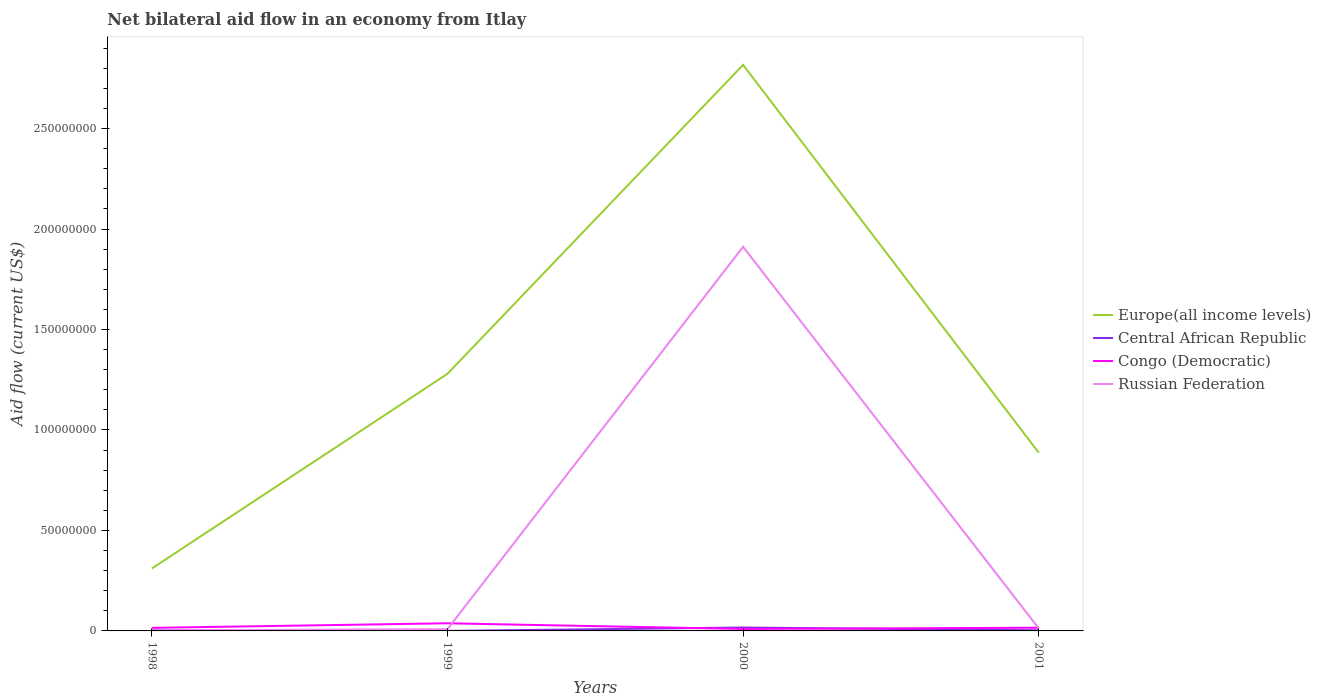How many different coloured lines are there?
Offer a very short reply. 4. Does the line corresponding to Russian Federation intersect with the line corresponding to Congo (Democratic)?
Your response must be concise. Yes. Is the number of lines equal to the number of legend labels?
Offer a very short reply. Yes. What is the total net bilateral aid flow in Congo (Democratic) in the graph?
Make the answer very short. -2.28e+06. What is the difference between the highest and the second highest net bilateral aid flow in Europe(all income levels)?
Your answer should be compact. 2.51e+08. What is the difference between the highest and the lowest net bilateral aid flow in Europe(all income levels)?
Offer a very short reply. 1. How many lines are there?
Provide a short and direct response. 4. What is the difference between two consecutive major ticks on the Y-axis?
Your answer should be compact. 5.00e+07. Where does the legend appear in the graph?
Make the answer very short. Center right. How are the legend labels stacked?
Ensure brevity in your answer.  Vertical. What is the title of the graph?
Your answer should be very brief. Net bilateral aid flow in an economy from Itlay. What is the label or title of the Y-axis?
Provide a short and direct response. Aid flow (current US$). What is the Aid flow (current US$) of Europe(all income levels) in 1998?
Provide a succinct answer. 3.11e+07. What is the Aid flow (current US$) of Congo (Democratic) in 1998?
Keep it short and to the point. 1.52e+06. What is the Aid flow (current US$) of Russian Federation in 1998?
Provide a succinct answer. 3.00e+05. What is the Aid flow (current US$) in Europe(all income levels) in 1999?
Your answer should be very brief. 1.28e+08. What is the Aid flow (current US$) of Central African Republic in 1999?
Provide a short and direct response. 10000. What is the Aid flow (current US$) of Congo (Democratic) in 1999?
Offer a terse response. 3.80e+06. What is the Aid flow (current US$) in Russian Federation in 1999?
Your answer should be compact. 8.80e+05. What is the Aid flow (current US$) in Europe(all income levels) in 2000?
Your answer should be very brief. 2.82e+08. What is the Aid flow (current US$) of Central African Republic in 2000?
Provide a short and direct response. 1.69e+06. What is the Aid flow (current US$) in Congo (Democratic) in 2000?
Your response must be concise. 9.60e+05. What is the Aid flow (current US$) of Russian Federation in 2000?
Your response must be concise. 1.91e+08. What is the Aid flow (current US$) in Europe(all income levels) in 2001?
Offer a very short reply. 8.87e+07. What is the Aid flow (current US$) in Congo (Democratic) in 2001?
Ensure brevity in your answer.  1.59e+06. What is the Aid flow (current US$) of Russian Federation in 2001?
Make the answer very short. 1.28e+06. Across all years, what is the maximum Aid flow (current US$) of Europe(all income levels)?
Provide a succinct answer. 2.82e+08. Across all years, what is the maximum Aid flow (current US$) in Central African Republic?
Keep it short and to the point. 1.69e+06. Across all years, what is the maximum Aid flow (current US$) in Congo (Democratic)?
Your response must be concise. 3.80e+06. Across all years, what is the maximum Aid flow (current US$) in Russian Federation?
Make the answer very short. 1.91e+08. Across all years, what is the minimum Aid flow (current US$) in Europe(all income levels)?
Offer a terse response. 3.11e+07. Across all years, what is the minimum Aid flow (current US$) of Central African Republic?
Provide a short and direct response. 10000. Across all years, what is the minimum Aid flow (current US$) in Congo (Democratic)?
Your answer should be compact. 9.60e+05. What is the total Aid flow (current US$) of Europe(all income levels) in the graph?
Give a very brief answer. 5.29e+08. What is the total Aid flow (current US$) of Central African Republic in the graph?
Offer a terse response. 2.34e+06. What is the total Aid flow (current US$) of Congo (Democratic) in the graph?
Your answer should be very brief. 7.87e+06. What is the total Aid flow (current US$) in Russian Federation in the graph?
Keep it short and to the point. 1.94e+08. What is the difference between the Aid flow (current US$) of Europe(all income levels) in 1998 and that in 1999?
Give a very brief answer. -9.69e+07. What is the difference between the Aid flow (current US$) of Central African Republic in 1998 and that in 1999?
Your answer should be compact. 3.10e+05. What is the difference between the Aid flow (current US$) in Congo (Democratic) in 1998 and that in 1999?
Provide a short and direct response. -2.28e+06. What is the difference between the Aid flow (current US$) of Russian Federation in 1998 and that in 1999?
Your response must be concise. -5.80e+05. What is the difference between the Aid flow (current US$) of Europe(all income levels) in 1998 and that in 2000?
Give a very brief answer. -2.51e+08. What is the difference between the Aid flow (current US$) in Central African Republic in 1998 and that in 2000?
Your response must be concise. -1.37e+06. What is the difference between the Aid flow (current US$) in Congo (Democratic) in 1998 and that in 2000?
Keep it short and to the point. 5.60e+05. What is the difference between the Aid flow (current US$) in Russian Federation in 1998 and that in 2000?
Your answer should be very brief. -1.91e+08. What is the difference between the Aid flow (current US$) in Europe(all income levels) in 1998 and that in 2001?
Give a very brief answer. -5.77e+07. What is the difference between the Aid flow (current US$) in Central African Republic in 1998 and that in 2001?
Your answer should be compact. 0. What is the difference between the Aid flow (current US$) of Russian Federation in 1998 and that in 2001?
Your answer should be compact. -9.80e+05. What is the difference between the Aid flow (current US$) in Europe(all income levels) in 1999 and that in 2000?
Your answer should be very brief. -1.54e+08. What is the difference between the Aid flow (current US$) of Central African Republic in 1999 and that in 2000?
Offer a very short reply. -1.68e+06. What is the difference between the Aid flow (current US$) of Congo (Democratic) in 1999 and that in 2000?
Ensure brevity in your answer.  2.84e+06. What is the difference between the Aid flow (current US$) in Russian Federation in 1999 and that in 2000?
Provide a short and direct response. -1.90e+08. What is the difference between the Aid flow (current US$) of Europe(all income levels) in 1999 and that in 2001?
Give a very brief answer. 3.92e+07. What is the difference between the Aid flow (current US$) of Central African Republic in 1999 and that in 2001?
Provide a succinct answer. -3.10e+05. What is the difference between the Aid flow (current US$) of Congo (Democratic) in 1999 and that in 2001?
Offer a very short reply. 2.21e+06. What is the difference between the Aid flow (current US$) of Russian Federation in 1999 and that in 2001?
Offer a very short reply. -4.00e+05. What is the difference between the Aid flow (current US$) in Europe(all income levels) in 2000 and that in 2001?
Offer a terse response. 1.93e+08. What is the difference between the Aid flow (current US$) in Central African Republic in 2000 and that in 2001?
Your response must be concise. 1.37e+06. What is the difference between the Aid flow (current US$) in Congo (Democratic) in 2000 and that in 2001?
Provide a short and direct response. -6.30e+05. What is the difference between the Aid flow (current US$) in Russian Federation in 2000 and that in 2001?
Your answer should be compact. 1.90e+08. What is the difference between the Aid flow (current US$) of Europe(all income levels) in 1998 and the Aid flow (current US$) of Central African Republic in 1999?
Your answer should be very brief. 3.10e+07. What is the difference between the Aid flow (current US$) in Europe(all income levels) in 1998 and the Aid flow (current US$) in Congo (Democratic) in 1999?
Offer a terse response. 2.73e+07. What is the difference between the Aid flow (current US$) in Europe(all income levels) in 1998 and the Aid flow (current US$) in Russian Federation in 1999?
Provide a short and direct response. 3.02e+07. What is the difference between the Aid flow (current US$) in Central African Republic in 1998 and the Aid flow (current US$) in Congo (Democratic) in 1999?
Make the answer very short. -3.48e+06. What is the difference between the Aid flow (current US$) in Central African Republic in 1998 and the Aid flow (current US$) in Russian Federation in 1999?
Provide a succinct answer. -5.60e+05. What is the difference between the Aid flow (current US$) in Congo (Democratic) in 1998 and the Aid flow (current US$) in Russian Federation in 1999?
Your response must be concise. 6.40e+05. What is the difference between the Aid flow (current US$) of Europe(all income levels) in 1998 and the Aid flow (current US$) of Central African Republic in 2000?
Give a very brief answer. 2.94e+07. What is the difference between the Aid flow (current US$) in Europe(all income levels) in 1998 and the Aid flow (current US$) in Congo (Democratic) in 2000?
Your answer should be compact. 3.01e+07. What is the difference between the Aid flow (current US$) in Europe(all income levels) in 1998 and the Aid flow (current US$) in Russian Federation in 2000?
Make the answer very short. -1.60e+08. What is the difference between the Aid flow (current US$) of Central African Republic in 1998 and the Aid flow (current US$) of Congo (Democratic) in 2000?
Ensure brevity in your answer.  -6.40e+05. What is the difference between the Aid flow (current US$) in Central African Republic in 1998 and the Aid flow (current US$) in Russian Federation in 2000?
Provide a short and direct response. -1.91e+08. What is the difference between the Aid flow (current US$) in Congo (Democratic) in 1998 and the Aid flow (current US$) in Russian Federation in 2000?
Your answer should be very brief. -1.90e+08. What is the difference between the Aid flow (current US$) of Europe(all income levels) in 1998 and the Aid flow (current US$) of Central African Republic in 2001?
Your response must be concise. 3.07e+07. What is the difference between the Aid flow (current US$) in Europe(all income levels) in 1998 and the Aid flow (current US$) in Congo (Democratic) in 2001?
Make the answer very short. 2.95e+07. What is the difference between the Aid flow (current US$) of Europe(all income levels) in 1998 and the Aid flow (current US$) of Russian Federation in 2001?
Keep it short and to the point. 2.98e+07. What is the difference between the Aid flow (current US$) of Central African Republic in 1998 and the Aid flow (current US$) of Congo (Democratic) in 2001?
Give a very brief answer. -1.27e+06. What is the difference between the Aid flow (current US$) of Central African Republic in 1998 and the Aid flow (current US$) of Russian Federation in 2001?
Keep it short and to the point. -9.60e+05. What is the difference between the Aid flow (current US$) of Congo (Democratic) in 1998 and the Aid flow (current US$) of Russian Federation in 2001?
Your answer should be compact. 2.40e+05. What is the difference between the Aid flow (current US$) in Europe(all income levels) in 1999 and the Aid flow (current US$) in Central African Republic in 2000?
Your answer should be compact. 1.26e+08. What is the difference between the Aid flow (current US$) of Europe(all income levels) in 1999 and the Aid flow (current US$) of Congo (Democratic) in 2000?
Keep it short and to the point. 1.27e+08. What is the difference between the Aid flow (current US$) of Europe(all income levels) in 1999 and the Aid flow (current US$) of Russian Federation in 2000?
Ensure brevity in your answer.  -6.32e+07. What is the difference between the Aid flow (current US$) in Central African Republic in 1999 and the Aid flow (current US$) in Congo (Democratic) in 2000?
Offer a very short reply. -9.50e+05. What is the difference between the Aid flow (current US$) of Central African Republic in 1999 and the Aid flow (current US$) of Russian Federation in 2000?
Give a very brief answer. -1.91e+08. What is the difference between the Aid flow (current US$) in Congo (Democratic) in 1999 and the Aid flow (current US$) in Russian Federation in 2000?
Offer a very short reply. -1.87e+08. What is the difference between the Aid flow (current US$) in Europe(all income levels) in 1999 and the Aid flow (current US$) in Central African Republic in 2001?
Make the answer very short. 1.28e+08. What is the difference between the Aid flow (current US$) in Europe(all income levels) in 1999 and the Aid flow (current US$) in Congo (Democratic) in 2001?
Give a very brief answer. 1.26e+08. What is the difference between the Aid flow (current US$) of Europe(all income levels) in 1999 and the Aid flow (current US$) of Russian Federation in 2001?
Your answer should be very brief. 1.27e+08. What is the difference between the Aid flow (current US$) in Central African Republic in 1999 and the Aid flow (current US$) in Congo (Democratic) in 2001?
Offer a terse response. -1.58e+06. What is the difference between the Aid flow (current US$) in Central African Republic in 1999 and the Aid flow (current US$) in Russian Federation in 2001?
Ensure brevity in your answer.  -1.27e+06. What is the difference between the Aid flow (current US$) of Congo (Democratic) in 1999 and the Aid flow (current US$) of Russian Federation in 2001?
Offer a terse response. 2.52e+06. What is the difference between the Aid flow (current US$) of Europe(all income levels) in 2000 and the Aid flow (current US$) of Central African Republic in 2001?
Your answer should be compact. 2.81e+08. What is the difference between the Aid flow (current US$) in Europe(all income levels) in 2000 and the Aid flow (current US$) in Congo (Democratic) in 2001?
Provide a succinct answer. 2.80e+08. What is the difference between the Aid flow (current US$) of Europe(all income levels) in 2000 and the Aid flow (current US$) of Russian Federation in 2001?
Ensure brevity in your answer.  2.80e+08. What is the difference between the Aid flow (current US$) in Central African Republic in 2000 and the Aid flow (current US$) in Congo (Democratic) in 2001?
Ensure brevity in your answer.  1.00e+05. What is the difference between the Aid flow (current US$) in Central African Republic in 2000 and the Aid flow (current US$) in Russian Federation in 2001?
Keep it short and to the point. 4.10e+05. What is the difference between the Aid flow (current US$) in Congo (Democratic) in 2000 and the Aid flow (current US$) in Russian Federation in 2001?
Your response must be concise. -3.20e+05. What is the average Aid flow (current US$) in Europe(all income levels) per year?
Provide a short and direct response. 1.32e+08. What is the average Aid flow (current US$) in Central African Republic per year?
Ensure brevity in your answer.  5.85e+05. What is the average Aid flow (current US$) of Congo (Democratic) per year?
Your answer should be compact. 1.97e+06. What is the average Aid flow (current US$) in Russian Federation per year?
Keep it short and to the point. 4.84e+07. In the year 1998, what is the difference between the Aid flow (current US$) of Europe(all income levels) and Aid flow (current US$) of Central African Republic?
Offer a terse response. 3.07e+07. In the year 1998, what is the difference between the Aid flow (current US$) in Europe(all income levels) and Aid flow (current US$) in Congo (Democratic)?
Offer a very short reply. 2.95e+07. In the year 1998, what is the difference between the Aid flow (current US$) of Europe(all income levels) and Aid flow (current US$) of Russian Federation?
Your answer should be very brief. 3.08e+07. In the year 1998, what is the difference between the Aid flow (current US$) in Central African Republic and Aid flow (current US$) in Congo (Democratic)?
Provide a short and direct response. -1.20e+06. In the year 1998, what is the difference between the Aid flow (current US$) of Congo (Democratic) and Aid flow (current US$) of Russian Federation?
Offer a terse response. 1.22e+06. In the year 1999, what is the difference between the Aid flow (current US$) in Europe(all income levels) and Aid flow (current US$) in Central African Republic?
Keep it short and to the point. 1.28e+08. In the year 1999, what is the difference between the Aid flow (current US$) of Europe(all income levels) and Aid flow (current US$) of Congo (Democratic)?
Offer a terse response. 1.24e+08. In the year 1999, what is the difference between the Aid flow (current US$) in Europe(all income levels) and Aid flow (current US$) in Russian Federation?
Offer a terse response. 1.27e+08. In the year 1999, what is the difference between the Aid flow (current US$) in Central African Republic and Aid flow (current US$) in Congo (Democratic)?
Offer a terse response. -3.79e+06. In the year 1999, what is the difference between the Aid flow (current US$) of Central African Republic and Aid flow (current US$) of Russian Federation?
Your response must be concise. -8.70e+05. In the year 1999, what is the difference between the Aid flow (current US$) of Congo (Democratic) and Aid flow (current US$) of Russian Federation?
Provide a succinct answer. 2.92e+06. In the year 2000, what is the difference between the Aid flow (current US$) of Europe(all income levels) and Aid flow (current US$) of Central African Republic?
Provide a short and direct response. 2.80e+08. In the year 2000, what is the difference between the Aid flow (current US$) of Europe(all income levels) and Aid flow (current US$) of Congo (Democratic)?
Offer a very short reply. 2.81e+08. In the year 2000, what is the difference between the Aid flow (current US$) in Europe(all income levels) and Aid flow (current US$) in Russian Federation?
Give a very brief answer. 9.05e+07. In the year 2000, what is the difference between the Aid flow (current US$) in Central African Republic and Aid flow (current US$) in Congo (Democratic)?
Offer a terse response. 7.30e+05. In the year 2000, what is the difference between the Aid flow (current US$) in Central African Republic and Aid flow (current US$) in Russian Federation?
Offer a very short reply. -1.89e+08. In the year 2000, what is the difference between the Aid flow (current US$) of Congo (Democratic) and Aid flow (current US$) of Russian Federation?
Make the answer very short. -1.90e+08. In the year 2001, what is the difference between the Aid flow (current US$) of Europe(all income levels) and Aid flow (current US$) of Central African Republic?
Give a very brief answer. 8.84e+07. In the year 2001, what is the difference between the Aid flow (current US$) of Europe(all income levels) and Aid flow (current US$) of Congo (Democratic)?
Keep it short and to the point. 8.71e+07. In the year 2001, what is the difference between the Aid flow (current US$) in Europe(all income levels) and Aid flow (current US$) in Russian Federation?
Make the answer very short. 8.74e+07. In the year 2001, what is the difference between the Aid flow (current US$) of Central African Republic and Aid flow (current US$) of Congo (Democratic)?
Your answer should be very brief. -1.27e+06. In the year 2001, what is the difference between the Aid flow (current US$) of Central African Republic and Aid flow (current US$) of Russian Federation?
Give a very brief answer. -9.60e+05. What is the ratio of the Aid flow (current US$) of Europe(all income levels) in 1998 to that in 1999?
Keep it short and to the point. 0.24. What is the ratio of the Aid flow (current US$) in Congo (Democratic) in 1998 to that in 1999?
Your answer should be compact. 0.4. What is the ratio of the Aid flow (current US$) of Russian Federation in 1998 to that in 1999?
Your answer should be compact. 0.34. What is the ratio of the Aid flow (current US$) of Europe(all income levels) in 1998 to that in 2000?
Your answer should be compact. 0.11. What is the ratio of the Aid flow (current US$) in Central African Republic in 1998 to that in 2000?
Offer a terse response. 0.19. What is the ratio of the Aid flow (current US$) of Congo (Democratic) in 1998 to that in 2000?
Keep it short and to the point. 1.58. What is the ratio of the Aid flow (current US$) of Russian Federation in 1998 to that in 2000?
Give a very brief answer. 0. What is the ratio of the Aid flow (current US$) of Europe(all income levels) in 1998 to that in 2001?
Ensure brevity in your answer.  0.35. What is the ratio of the Aid flow (current US$) in Congo (Democratic) in 1998 to that in 2001?
Ensure brevity in your answer.  0.96. What is the ratio of the Aid flow (current US$) in Russian Federation in 1998 to that in 2001?
Your answer should be compact. 0.23. What is the ratio of the Aid flow (current US$) in Europe(all income levels) in 1999 to that in 2000?
Your answer should be compact. 0.45. What is the ratio of the Aid flow (current US$) in Central African Republic in 1999 to that in 2000?
Provide a short and direct response. 0.01. What is the ratio of the Aid flow (current US$) in Congo (Democratic) in 1999 to that in 2000?
Make the answer very short. 3.96. What is the ratio of the Aid flow (current US$) of Russian Federation in 1999 to that in 2000?
Keep it short and to the point. 0. What is the ratio of the Aid flow (current US$) of Europe(all income levels) in 1999 to that in 2001?
Offer a terse response. 1.44. What is the ratio of the Aid flow (current US$) in Central African Republic in 1999 to that in 2001?
Your response must be concise. 0.03. What is the ratio of the Aid flow (current US$) in Congo (Democratic) in 1999 to that in 2001?
Provide a short and direct response. 2.39. What is the ratio of the Aid flow (current US$) of Russian Federation in 1999 to that in 2001?
Offer a very short reply. 0.69. What is the ratio of the Aid flow (current US$) of Europe(all income levels) in 2000 to that in 2001?
Give a very brief answer. 3.17. What is the ratio of the Aid flow (current US$) of Central African Republic in 2000 to that in 2001?
Keep it short and to the point. 5.28. What is the ratio of the Aid flow (current US$) in Congo (Democratic) in 2000 to that in 2001?
Your answer should be compact. 0.6. What is the ratio of the Aid flow (current US$) in Russian Federation in 2000 to that in 2001?
Provide a short and direct response. 149.34. What is the difference between the highest and the second highest Aid flow (current US$) in Europe(all income levels)?
Make the answer very short. 1.54e+08. What is the difference between the highest and the second highest Aid flow (current US$) in Central African Republic?
Your answer should be compact. 1.37e+06. What is the difference between the highest and the second highest Aid flow (current US$) in Congo (Democratic)?
Provide a succinct answer. 2.21e+06. What is the difference between the highest and the second highest Aid flow (current US$) in Russian Federation?
Keep it short and to the point. 1.90e+08. What is the difference between the highest and the lowest Aid flow (current US$) of Europe(all income levels)?
Your answer should be compact. 2.51e+08. What is the difference between the highest and the lowest Aid flow (current US$) of Central African Republic?
Provide a succinct answer. 1.68e+06. What is the difference between the highest and the lowest Aid flow (current US$) of Congo (Democratic)?
Provide a succinct answer. 2.84e+06. What is the difference between the highest and the lowest Aid flow (current US$) of Russian Federation?
Keep it short and to the point. 1.91e+08. 